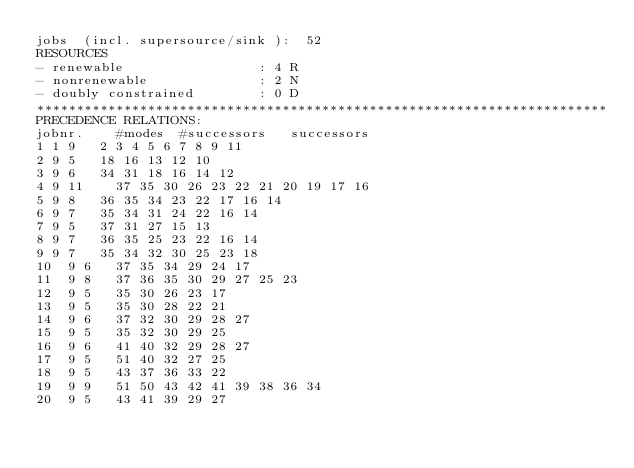<code> <loc_0><loc_0><loc_500><loc_500><_ObjectiveC_>jobs  (incl. supersource/sink ):	52
RESOURCES
- renewable                 : 4 R
- nonrenewable              : 2 N
- doubly constrained        : 0 D
************************************************************************
PRECEDENCE RELATIONS:
jobnr.    #modes  #successors   successors
1	1	9		2 3 4 5 6 7 8 9 11 
2	9	5		18 16 13 12 10 
3	9	6		34 31 18 16 14 12 
4	9	11		37 35 30 26 23 22 21 20 19 17 16 
5	9	8		36 35 34 23 22 17 16 14 
6	9	7		35 34 31 24 22 16 14 
7	9	5		37 31 27 15 13 
8	9	7		36 35 25 23 22 16 14 
9	9	7		35 34 32 30 25 23 18 
10	9	6		37 35 34 29 24 17 
11	9	8		37 36 35 30 29 27 25 23 
12	9	5		35 30 26 23 17 
13	9	5		35 30 28 22 21 
14	9	6		37 32 30 29 28 27 
15	9	5		35 32 30 29 25 
16	9	6		41 40 32 29 28 27 
17	9	5		51 40 32 27 25 
18	9	5		43 37 36 33 22 
19	9	9		51 50 43 42 41 39 38 36 34 
20	9	5		43 41 39 29 27 </code> 